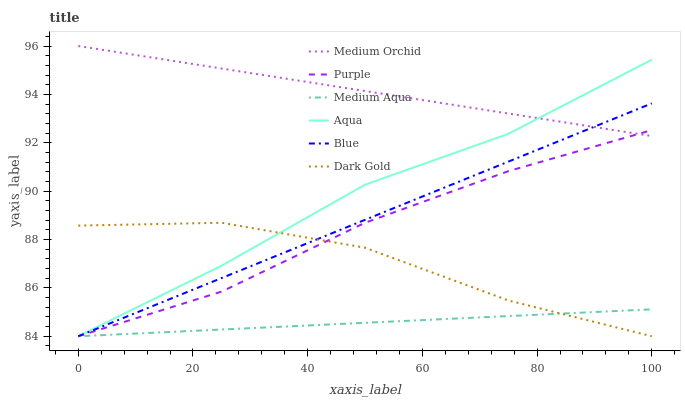Does Medium Aqua have the minimum area under the curve?
Answer yes or no. Yes. Does Medium Orchid have the maximum area under the curve?
Answer yes or no. Yes. Does Dark Gold have the minimum area under the curve?
Answer yes or no. No. Does Dark Gold have the maximum area under the curve?
Answer yes or no. No. Is Blue the smoothest?
Answer yes or no. Yes. Is Dark Gold the roughest?
Answer yes or no. Yes. Is Purple the smoothest?
Answer yes or no. No. Is Purple the roughest?
Answer yes or no. No. Does Blue have the lowest value?
Answer yes or no. Yes. Does Medium Orchid have the lowest value?
Answer yes or no. No. Does Medium Orchid have the highest value?
Answer yes or no. Yes. Does Dark Gold have the highest value?
Answer yes or no. No. Is Dark Gold less than Medium Orchid?
Answer yes or no. Yes. Is Medium Orchid greater than Dark Gold?
Answer yes or no. Yes. Does Blue intersect Medium Orchid?
Answer yes or no. Yes. Is Blue less than Medium Orchid?
Answer yes or no. No. Is Blue greater than Medium Orchid?
Answer yes or no. No. Does Dark Gold intersect Medium Orchid?
Answer yes or no. No. 